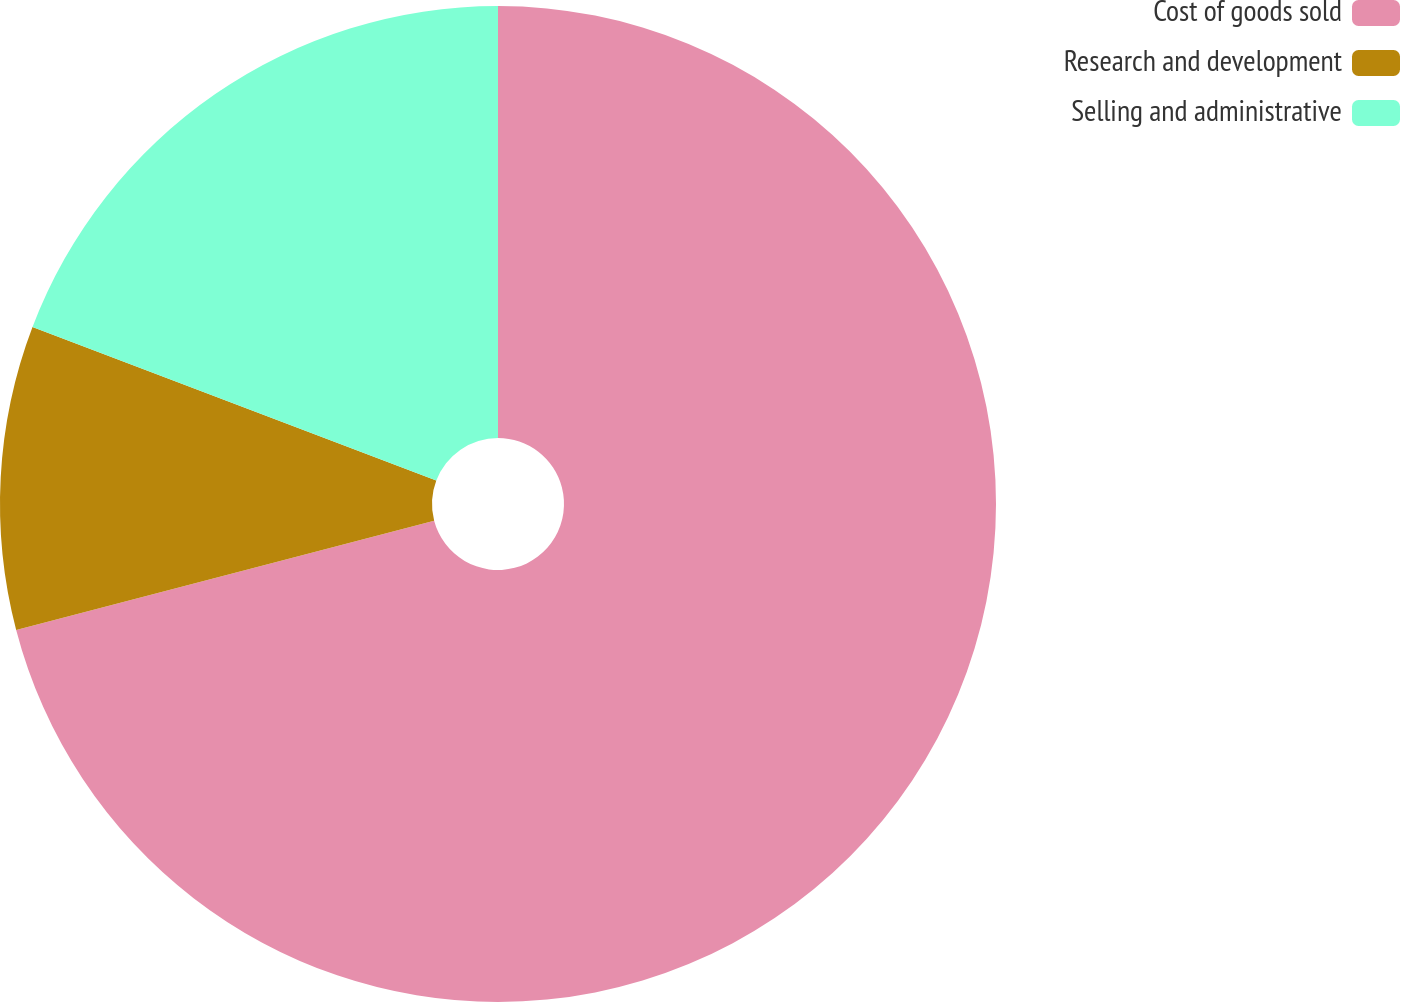Convert chart. <chart><loc_0><loc_0><loc_500><loc_500><pie_chart><fcel>Cost of goods sold<fcel>Research and development<fcel>Selling and administrative<nl><fcel>70.94%<fcel>9.85%<fcel>19.22%<nl></chart> 